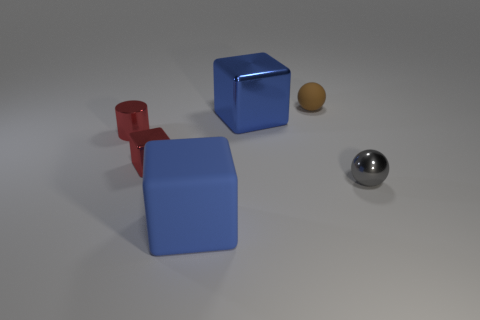Subtract all tiny cubes. How many cubes are left? 2 Add 3 red things. How many objects exist? 9 Subtract all brown spheres. How many spheres are left? 1 Subtract 1 spheres. How many spheres are left? 1 Subtract all cylinders. How many objects are left? 5 Subtract all yellow balls. Subtract all blue blocks. How many balls are left? 2 Subtract all large green metallic cubes. Subtract all blue rubber blocks. How many objects are left? 5 Add 1 blue things. How many blue things are left? 3 Add 1 tiny rubber spheres. How many tiny rubber spheres exist? 2 Subtract 0 purple spheres. How many objects are left? 6 